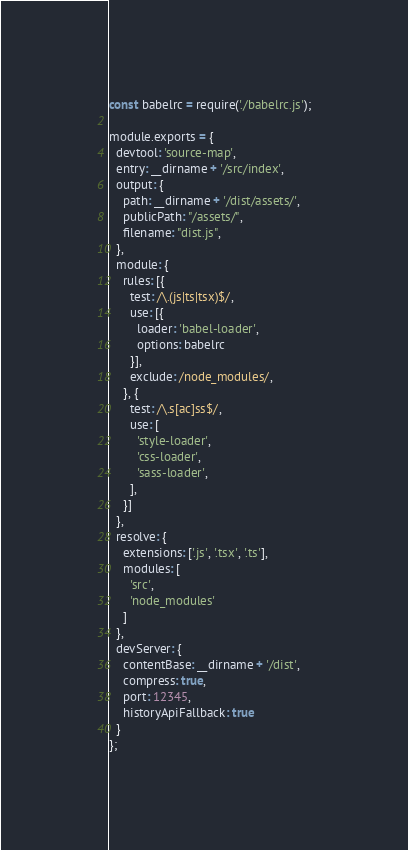<code> <loc_0><loc_0><loc_500><loc_500><_JavaScript_>
const babelrc = require('./babelrc.js');

module.exports = {
  devtool: 'source-map',
  entry: __dirname + '/src/index',
  output: {
    path: __dirname + '/dist/assets/',
    publicPath: "/assets/",
    filename: "dist.js",
  },
  module: {
    rules: [{
      test: /\.(js|ts|tsx)$/,
      use: [{
        loader: 'babel-loader',
        options: babelrc
      }],
      exclude: /node_modules/,
    }, {
      test: /\.s[ac]ss$/,
      use: [
        'style-loader',
        'css-loader',
        'sass-loader',
      ],
    }]
  },
  resolve: {
    extensions: ['.js', '.tsx', '.ts'],
    modules: [
      'src',
      'node_modules'
    ]   
  },
  devServer: {
    contentBase: __dirname + '/dist',
    compress: true,
    port: 12345,
    historyApiFallback: true
  }
};</code> 